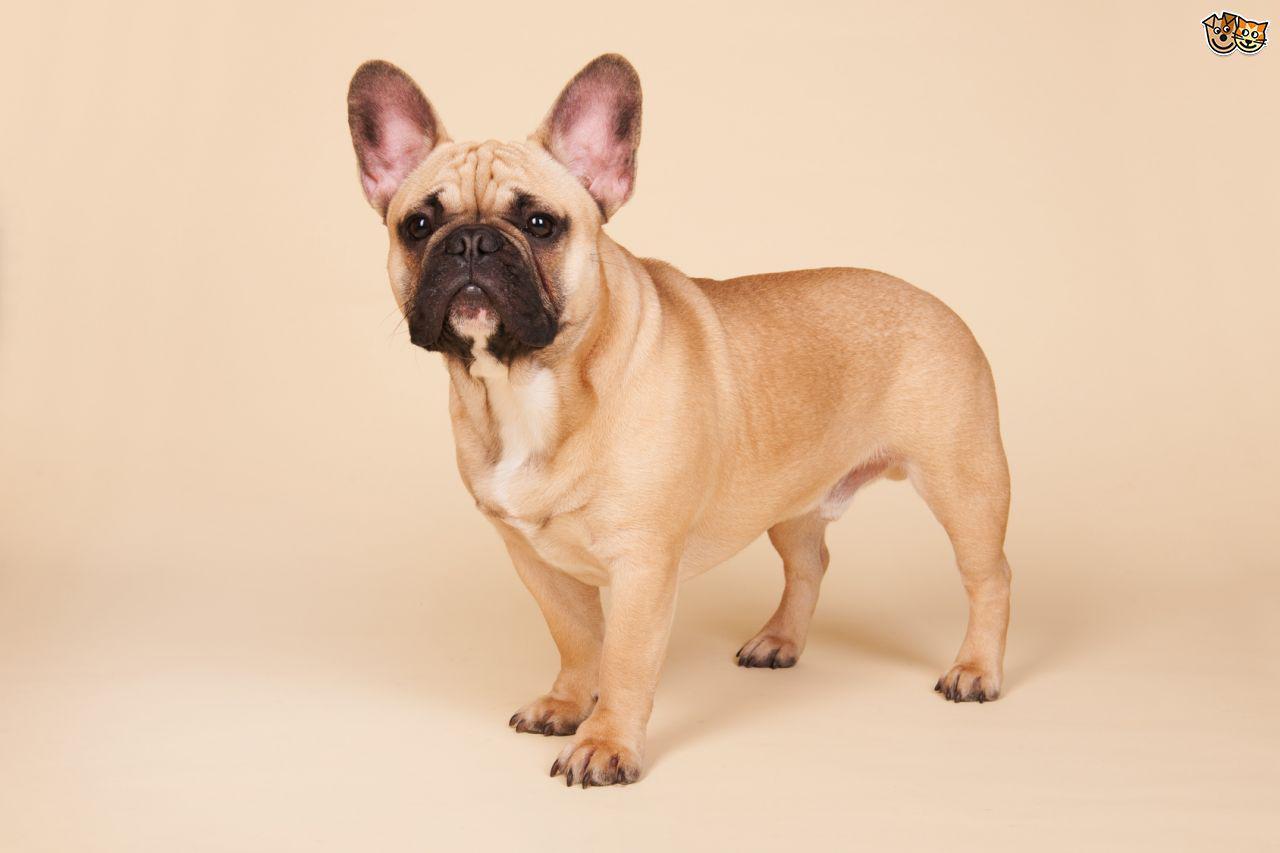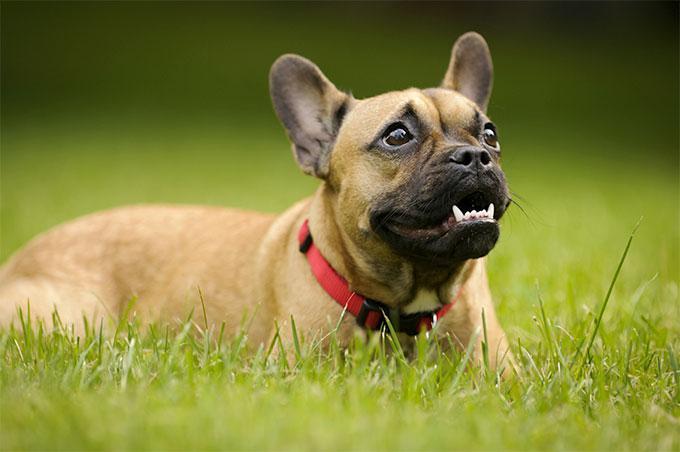The first image is the image on the left, the second image is the image on the right. For the images shown, is this caption "The dog in the image on the right is mostly black." true? Answer yes or no. No. 